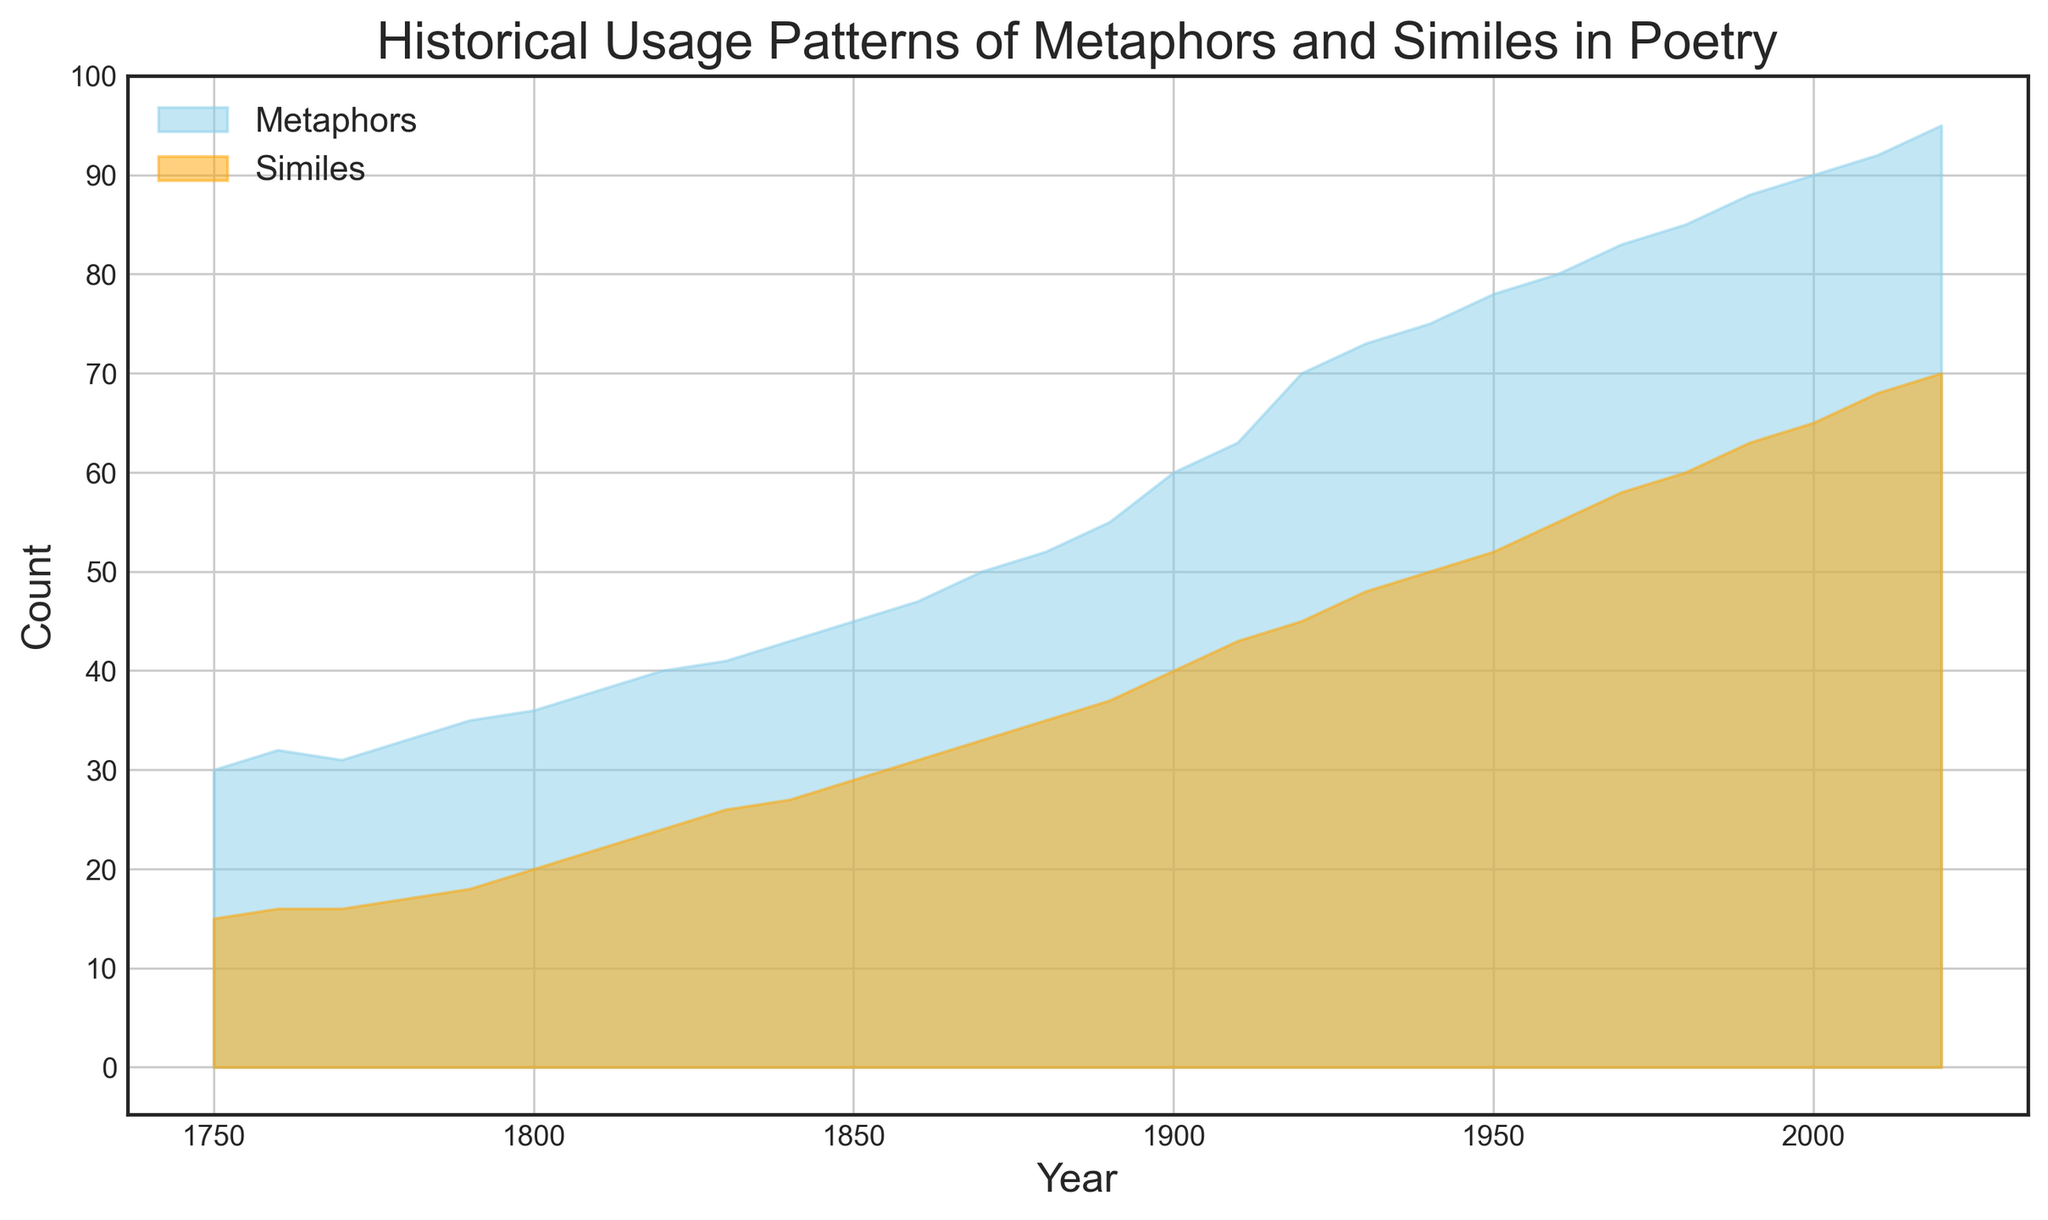What year did metaphors first surpass 50 in usage? From the plot, observe the point where the 'Metaphors' curve crosses 50 on the y-axis. This occurs around 1870.
Answer: 1870 What is the difference in the usage of metaphors and similes in 1920? Find the values for both metaphors (70) and similes (45) in 1920 and calculate the difference: 70 - 45 = 25.
Answer: 25 Which literary device saw a more significant increase from 2000 to 2010? Compare the increase for metaphors (92-90 = 2) and similes (68-65 = 3). Similes show a higher increase.
Answer: Similes Between 1900 and 1950, by how much did the usage of similes increase? Look at the values in 1900 (40) and 1950 (52) and find the difference: 52 - 40 = 12.
Answer: 12 When did both metaphors and similes show the same increasing trend? Throughout the timeline, especially post-1900, both curves demonstrate an increasing trend, with no year showing an exact match but both increasing simultaneously.
Answer: Post-1900 In which decade did metaphors reach a count of 60? Identify when the 'Metaphors' curve hits 60. It occurs in the early 1900s.
Answer: Early 1900s How much larger was the usage of metaphors than similes in 1980? Find the values for metaphors (85) and similes (60) in 1980, then calculate the difference: 85 - 60 = 25.
Answer: 25 Which year marks the first steep increase for both literary devices? Observe the plot for the first significant upward trend. It starts around 1900-1910 for both metaphors and similes.
Answer: 1900-1910 Are there any years where similes did not increase? Review the plot for any period where the 'Similes' curve is flat or decreases. All observed years show an increase.
Answer: No 